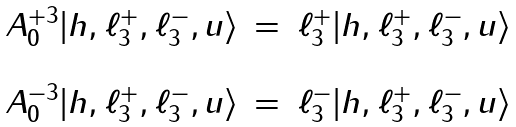<formula> <loc_0><loc_0><loc_500><loc_500>\begin{array} { l l l } { { A _ { 0 } ^ { + 3 } | h , \ell _ { 3 } ^ { + } , \ell _ { 3 } ^ { - } , u \rangle } } & { = } & { { \ell _ { 3 } ^ { + } | h , \ell _ { 3 } ^ { + } , \ell _ { 3 } ^ { - } , u \rangle } } \\ { \ } & { \ } \\ { { A _ { 0 } ^ { - 3 } | h , \ell _ { 3 } ^ { + } , \ell _ { 3 } ^ { - } , u \rangle } } & { = } & { { \ell _ { 3 } ^ { - } | h , \ell _ { 3 } ^ { + } , \ell _ { 3 } ^ { - } , u \rangle } } \end{array}</formula> 